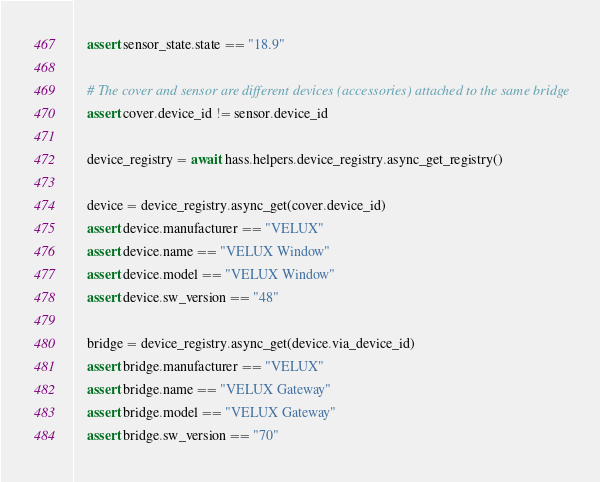<code> <loc_0><loc_0><loc_500><loc_500><_Python_>    assert sensor_state.state == "18.9"

    # The cover and sensor are different devices (accessories) attached to the same bridge
    assert cover.device_id != sensor.device_id

    device_registry = await hass.helpers.device_registry.async_get_registry()

    device = device_registry.async_get(cover.device_id)
    assert device.manufacturer == "VELUX"
    assert device.name == "VELUX Window"
    assert device.model == "VELUX Window"
    assert device.sw_version == "48"

    bridge = device_registry.async_get(device.via_device_id)
    assert bridge.manufacturer == "VELUX"
    assert bridge.name == "VELUX Gateway"
    assert bridge.model == "VELUX Gateway"
    assert bridge.sw_version == "70"
</code> 